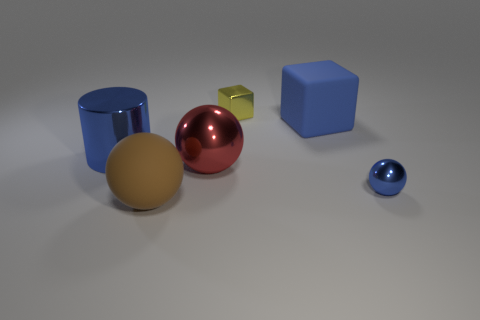Are there more large red metal balls in front of the large red thing than red metal spheres?
Provide a succinct answer. No. What shape is the blue thing that is on the right side of the cylinder and to the left of the blue metal sphere?
Provide a short and direct response. Cube. Is the size of the brown rubber object the same as the shiny cube?
Your answer should be very brief. No. There is a red metal sphere; how many matte blocks are in front of it?
Your answer should be compact. 0. Is the number of red metallic spheres that are left of the large red metallic ball the same as the number of blocks left of the large brown rubber object?
Provide a succinct answer. Yes. There is a object that is right of the big rubber cube; is it the same shape as the blue rubber object?
Offer a very short reply. No. Are there any other things that have the same material as the small cube?
Your response must be concise. Yes. There is a blue matte thing; does it have the same size as the ball behind the tiny sphere?
Your answer should be very brief. Yes. How many other things are the same color as the big rubber cube?
Your response must be concise. 2. There is a large red metal object; are there any small metal balls behind it?
Keep it short and to the point. No. 